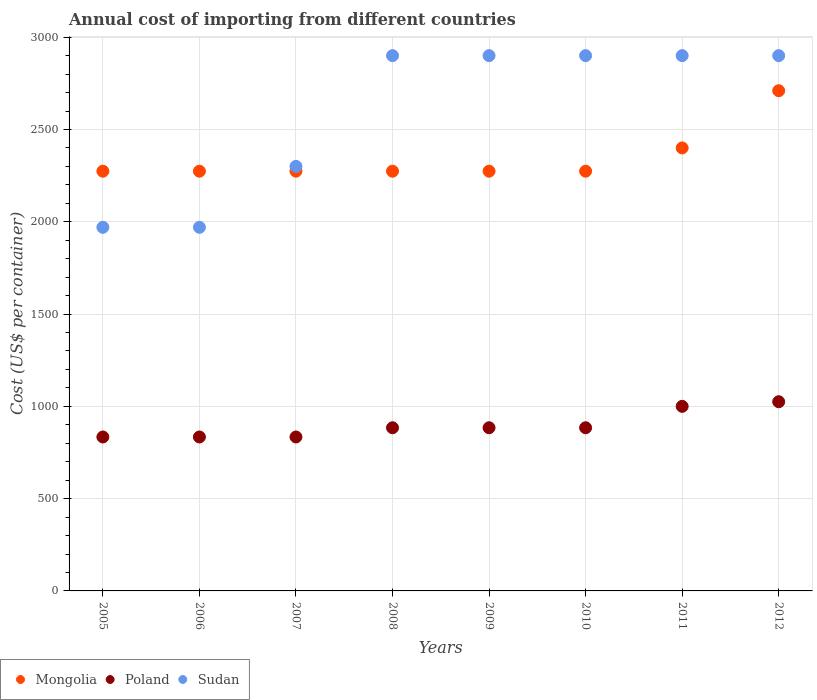What is the total annual cost of importing in Poland in 2005?
Your answer should be very brief. 834. Across all years, what is the maximum total annual cost of importing in Poland?
Keep it short and to the point. 1025. Across all years, what is the minimum total annual cost of importing in Poland?
Keep it short and to the point. 834. In which year was the total annual cost of importing in Sudan minimum?
Offer a very short reply. 2005. What is the total total annual cost of importing in Sudan in the graph?
Your answer should be very brief. 2.07e+04. What is the difference between the total annual cost of importing in Sudan in 2005 and that in 2011?
Ensure brevity in your answer.  -930. What is the difference between the total annual cost of importing in Poland in 2006 and the total annual cost of importing in Mongolia in 2007?
Your answer should be compact. -1440. What is the average total annual cost of importing in Mongolia per year?
Ensure brevity in your answer.  2344.25. In the year 2006, what is the difference between the total annual cost of importing in Sudan and total annual cost of importing in Mongolia?
Your answer should be very brief. -304. What is the difference between the highest and the second highest total annual cost of importing in Mongolia?
Give a very brief answer. 310. What is the difference between the highest and the lowest total annual cost of importing in Poland?
Make the answer very short. 191. In how many years, is the total annual cost of importing in Poland greater than the average total annual cost of importing in Poland taken over all years?
Your answer should be very brief. 2. Is it the case that in every year, the sum of the total annual cost of importing in Sudan and total annual cost of importing in Poland  is greater than the total annual cost of importing in Mongolia?
Give a very brief answer. Yes. Does the total annual cost of importing in Mongolia monotonically increase over the years?
Your response must be concise. No. Is the total annual cost of importing in Sudan strictly greater than the total annual cost of importing in Poland over the years?
Your answer should be very brief. Yes. Is the total annual cost of importing in Mongolia strictly less than the total annual cost of importing in Poland over the years?
Keep it short and to the point. No. How many dotlines are there?
Give a very brief answer. 3. What is the difference between two consecutive major ticks on the Y-axis?
Your answer should be compact. 500. Does the graph contain any zero values?
Your answer should be compact. No. Does the graph contain grids?
Keep it short and to the point. Yes. How many legend labels are there?
Your response must be concise. 3. What is the title of the graph?
Your answer should be compact. Annual cost of importing from different countries. What is the label or title of the Y-axis?
Give a very brief answer. Cost (US$ per container). What is the Cost (US$ per container) of Mongolia in 2005?
Offer a very short reply. 2274. What is the Cost (US$ per container) in Poland in 2005?
Your response must be concise. 834. What is the Cost (US$ per container) in Sudan in 2005?
Ensure brevity in your answer.  1970. What is the Cost (US$ per container) in Mongolia in 2006?
Keep it short and to the point. 2274. What is the Cost (US$ per container) of Poland in 2006?
Ensure brevity in your answer.  834. What is the Cost (US$ per container) of Sudan in 2006?
Your response must be concise. 1970. What is the Cost (US$ per container) in Mongolia in 2007?
Provide a short and direct response. 2274. What is the Cost (US$ per container) in Poland in 2007?
Keep it short and to the point. 834. What is the Cost (US$ per container) in Sudan in 2007?
Give a very brief answer. 2300. What is the Cost (US$ per container) of Mongolia in 2008?
Your answer should be compact. 2274. What is the Cost (US$ per container) of Poland in 2008?
Offer a terse response. 884. What is the Cost (US$ per container) in Sudan in 2008?
Offer a terse response. 2900. What is the Cost (US$ per container) of Mongolia in 2009?
Your answer should be very brief. 2274. What is the Cost (US$ per container) of Poland in 2009?
Your answer should be very brief. 884. What is the Cost (US$ per container) in Sudan in 2009?
Your answer should be very brief. 2900. What is the Cost (US$ per container) of Mongolia in 2010?
Make the answer very short. 2274. What is the Cost (US$ per container) of Poland in 2010?
Provide a succinct answer. 884. What is the Cost (US$ per container) in Sudan in 2010?
Provide a short and direct response. 2900. What is the Cost (US$ per container) of Mongolia in 2011?
Provide a short and direct response. 2400. What is the Cost (US$ per container) of Poland in 2011?
Give a very brief answer. 1000. What is the Cost (US$ per container) in Sudan in 2011?
Offer a very short reply. 2900. What is the Cost (US$ per container) of Mongolia in 2012?
Ensure brevity in your answer.  2710. What is the Cost (US$ per container) of Poland in 2012?
Provide a succinct answer. 1025. What is the Cost (US$ per container) of Sudan in 2012?
Offer a terse response. 2900. Across all years, what is the maximum Cost (US$ per container) in Mongolia?
Ensure brevity in your answer.  2710. Across all years, what is the maximum Cost (US$ per container) in Poland?
Your response must be concise. 1025. Across all years, what is the maximum Cost (US$ per container) in Sudan?
Offer a terse response. 2900. Across all years, what is the minimum Cost (US$ per container) of Mongolia?
Your response must be concise. 2274. Across all years, what is the minimum Cost (US$ per container) in Poland?
Offer a very short reply. 834. Across all years, what is the minimum Cost (US$ per container) of Sudan?
Provide a succinct answer. 1970. What is the total Cost (US$ per container) in Mongolia in the graph?
Your answer should be compact. 1.88e+04. What is the total Cost (US$ per container) of Poland in the graph?
Your answer should be very brief. 7179. What is the total Cost (US$ per container) in Sudan in the graph?
Offer a very short reply. 2.07e+04. What is the difference between the Cost (US$ per container) in Mongolia in 2005 and that in 2007?
Provide a short and direct response. 0. What is the difference between the Cost (US$ per container) of Poland in 2005 and that in 2007?
Offer a terse response. 0. What is the difference between the Cost (US$ per container) of Sudan in 2005 and that in 2007?
Keep it short and to the point. -330. What is the difference between the Cost (US$ per container) of Poland in 2005 and that in 2008?
Your answer should be very brief. -50. What is the difference between the Cost (US$ per container) in Sudan in 2005 and that in 2008?
Offer a terse response. -930. What is the difference between the Cost (US$ per container) in Sudan in 2005 and that in 2009?
Your response must be concise. -930. What is the difference between the Cost (US$ per container) of Mongolia in 2005 and that in 2010?
Your response must be concise. 0. What is the difference between the Cost (US$ per container) in Sudan in 2005 and that in 2010?
Provide a short and direct response. -930. What is the difference between the Cost (US$ per container) in Mongolia in 2005 and that in 2011?
Ensure brevity in your answer.  -126. What is the difference between the Cost (US$ per container) of Poland in 2005 and that in 2011?
Provide a short and direct response. -166. What is the difference between the Cost (US$ per container) of Sudan in 2005 and that in 2011?
Ensure brevity in your answer.  -930. What is the difference between the Cost (US$ per container) in Mongolia in 2005 and that in 2012?
Offer a terse response. -436. What is the difference between the Cost (US$ per container) of Poland in 2005 and that in 2012?
Your answer should be compact. -191. What is the difference between the Cost (US$ per container) of Sudan in 2005 and that in 2012?
Ensure brevity in your answer.  -930. What is the difference between the Cost (US$ per container) in Mongolia in 2006 and that in 2007?
Offer a terse response. 0. What is the difference between the Cost (US$ per container) in Sudan in 2006 and that in 2007?
Keep it short and to the point. -330. What is the difference between the Cost (US$ per container) in Poland in 2006 and that in 2008?
Your response must be concise. -50. What is the difference between the Cost (US$ per container) of Sudan in 2006 and that in 2008?
Ensure brevity in your answer.  -930. What is the difference between the Cost (US$ per container) in Mongolia in 2006 and that in 2009?
Your response must be concise. 0. What is the difference between the Cost (US$ per container) of Poland in 2006 and that in 2009?
Your answer should be compact. -50. What is the difference between the Cost (US$ per container) in Sudan in 2006 and that in 2009?
Your answer should be very brief. -930. What is the difference between the Cost (US$ per container) of Sudan in 2006 and that in 2010?
Your response must be concise. -930. What is the difference between the Cost (US$ per container) in Mongolia in 2006 and that in 2011?
Provide a succinct answer. -126. What is the difference between the Cost (US$ per container) in Poland in 2006 and that in 2011?
Offer a terse response. -166. What is the difference between the Cost (US$ per container) of Sudan in 2006 and that in 2011?
Offer a terse response. -930. What is the difference between the Cost (US$ per container) in Mongolia in 2006 and that in 2012?
Offer a terse response. -436. What is the difference between the Cost (US$ per container) in Poland in 2006 and that in 2012?
Ensure brevity in your answer.  -191. What is the difference between the Cost (US$ per container) of Sudan in 2006 and that in 2012?
Ensure brevity in your answer.  -930. What is the difference between the Cost (US$ per container) of Mongolia in 2007 and that in 2008?
Your answer should be very brief. 0. What is the difference between the Cost (US$ per container) in Sudan in 2007 and that in 2008?
Ensure brevity in your answer.  -600. What is the difference between the Cost (US$ per container) of Sudan in 2007 and that in 2009?
Make the answer very short. -600. What is the difference between the Cost (US$ per container) of Mongolia in 2007 and that in 2010?
Give a very brief answer. 0. What is the difference between the Cost (US$ per container) of Sudan in 2007 and that in 2010?
Offer a very short reply. -600. What is the difference between the Cost (US$ per container) of Mongolia in 2007 and that in 2011?
Offer a very short reply. -126. What is the difference between the Cost (US$ per container) of Poland in 2007 and that in 2011?
Offer a very short reply. -166. What is the difference between the Cost (US$ per container) in Sudan in 2007 and that in 2011?
Keep it short and to the point. -600. What is the difference between the Cost (US$ per container) of Mongolia in 2007 and that in 2012?
Ensure brevity in your answer.  -436. What is the difference between the Cost (US$ per container) in Poland in 2007 and that in 2012?
Provide a succinct answer. -191. What is the difference between the Cost (US$ per container) in Sudan in 2007 and that in 2012?
Ensure brevity in your answer.  -600. What is the difference between the Cost (US$ per container) of Mongolia in 2008 and that in 2009?
Make the answer very short. 0. What is the difference between the Cost (US$ per container) of Poland in 2008 and that in 2009?
Your response must be concise. 0. What is the difference between the Cost (US$ per container) in Sudan in 2008 and that in 2009?
Your response must be concise. 0. What is the difference between the Cost (US$ per container) in Poland in 2008 and that in 2010?
Provide a succinct answer. 0. What is the difference between the Cost (US$ per container) in Mongolia in 2008 and that in 2011?
Make the answer very short. -126. What is the difference between the Cost (US$ per container) of Poland in 2008 and that in 2011?
Ensure brevity in your answer.  -116. What is the difference between the Cost (US$ per container) in Mongolia in 2008 and that in 2012?
Offer a terse response. -436. What is the difference between the Cost (US$ per container) in Poland in 2008 and that in 2012?
Offer a very short reply. -141. What is the difference between the Cost (US$ per container) in Sudan in 2008 and that in 2012?
Make the answer very short. 0. What is the difference between the Cost (US$ per container) of Mongolia in 2009 and that in 2010?
Your answer should be compact. 0. What is the difference between the Cost (US$ per container) of Sudan in 2009 and that in 2010?
Make the answer very short. 0. What is the difference between the Cost (US$ per container) in Mongolia in 2009 and that in 2011?
Offer a very short reply. -126. What is the difference between the Cost (US$ per container) of Poland in 2009 and that in 2011?
Provide a succinct answer. -116. What is the difference between the Cost (US$ per container) in Mongolia in 2009 and that in 2012?
Provide a short and direct response. -436. What is the difference between the Cost (US$ per container) in Poland in 2009 and that in 2012?
Keep it short and to the point. -141. What is the difference between the Cost (US$ per container) of Mongolia in 2010 and that in 2011?
Ensure brevity in your answer.  -126. What is the difference between the Cost (US$ per container) of Poland in 2010 and that in 2011?
Your answer should be compact. -116. What is the difference between the Cost (US$ per container) of Mongolia in 2010 and that in 2012?
Ensure brevity in your answer.  -436. What is the difference between the Cost (US$ per container) in Poland in 2010 and that in 2012?
Your answer should be very brief. -141. What is the difference between the Cost (US$ per container) of Sudan in 2010 and that in 2012?
Make the answer very short. 0. What is the difference between the Cost (US$ per container) in Mongolia in 2011 and that in 2012?
Offer a very short reply. -310. What is the difference between the Cost (US$ per container) of Sudan in 2011 and that in 2012?
Provide a succinct answer. 0. What is the difference between the Cost (US$ per container) in Mongolia in 2005 and the Cost (US$ per container) in Poland in 2006?
Your answer should be very brief. 1440. What is the difference between the Cost (US$ per container) in Mongolia in 2005 and the Cost (US$ per container) in Sudan in 2006?
Keep it short and to the point. 304. What is the difference between the Cost (US$ per container) in Poland in 2005 and the Cost (US$ per container) in Sudan in 2006?
Offer a terse response. -1136. What is the difference between the Cost (US$ per container) of Mongolia in 2005 and the Cost (US$ per container) of Poland in 2007?
Provide a short and direct response. 1440. What is the difference between the Cost (US$ per container) of Poland in 2005 and the Cost (US$ per container) of Sudan in 2007?
Your response must be concise. -1466. What is the difference between the Cost (US$ per container) of Mongolia in 2005 and the Cost (US$ per container) of Poland in 2008?
Your answer should be compact. 1390. What is the difference between the Cost (US$ per container) in Mongolia in 2005 and the Cost (US$ per container) in Sudan in 2008?
Provide a succinct answer. -626. What is the difference between the Cost (US$ per container) in Poland in 2005 and the Cost (US$ per container) in Sudan in 2008?
Offer a very short reply. -2066. What is the difference between the Cost (US$ per container) of Mongolia in 2005 and the Cost (US$ per container) of Poland in 2009?
Ensure brevity in your answer.  1390. What is the difference between the Cost (US$ per container) in Mongolia in 2005 and the Cost (US$ per container) in Sudan in 2009?
Your answer should be compact. -626. What is the difference between the Cost (US$ per container) of Poland in 2005 and the Cost (US$ per container) of Sudan in 2009?
Your response must be concise. -2066. What is the difference between the Cost (US$ per container) in Mongolia in 2005 and the Cost (US$ per container) in Poland in 2010?
Keep it short and to the point. 1390. What is the difference between the Cost (US$ per container) of Mongolia in 2005 and the Cost (US$ per container) of Sudan in 2010?
Keep it short and to the point. -626. What is the difference between the Cost (US$ per container) of Poland in 2005 and the Cost (US$ per container) of Sudan in 2010?
Offer a very short reply. -2066. What is the difference between the Cost (US$ per container) in Mongolia in 2005 and the Cost (US$ per container) in Poland in 2011?
Offer a terse response. 1274. What is the difference between the Cost (US$ per container) in Mongolia in 2005 and the Cost (US$ per container) in Sudan in 2011?
Make the answer very short. -626. What is the difference between the Cost (US$ per container) in Poland in 2005 and the Cost (US$ per container) in Sudan in 2011?
Give a very brief answer. -2066. What is the difference between the Cost (US$ per container) of Mongolia in 2005 and the Cost (US$ per container) of Poland in 2012?
Give a very brief answer. 1249. What is the difference between the Cost (US$ per container) in Mongolia in 2005 and the Cost (US$ per container) in Sudan in 2012?
Keep it short and to the point. -626. What is the difference between the Cost (US$ per container) in Poland in 2005 and the Cost (US$ per container) in Sudan in 2012?
Offer a terse response. -2066. What is the difference between the Cost (US$ per container) of Mongolia in 2006 and the Cost (US$ per container) of Poland in 2007?
Provide a short and direct response. 1440. What is the difference between the Cost (US$ per container) in Poland in 2006 and the Cost (US$ per container) in Sudan in 2007?
Offer a terse response. -1466. What is the difference between the Cost (US$ per container) in Mongolia in 2006 and the Cost (US$ per container) in Poland in 2008?
Give a very brief answer. 1390. What is the difference between the Cost (US$ per container) in Mongolia in 2006 and the Cost (US$ per container) in Sudan in 2008?
Offer a terse response. -626. What is the difference between the Cost (US$ per container) in Poland in 2006 and the Cost (US$ per container) in Sudan in 2008?
Your answer should be very brief. -2066. What is the difference between the Cost (US$ per container) of Mongolia in 2006 and the Cost (US$ per container) of Poland in 2009?
Provide a succinct answer. 1390. What is the difference between the Cost (US$ per container) of Mongolia in 2006 and the Cost (US$ per container) of Sudan in 2009?
Offer a very short reply. -626. What is the difference between the Cost (US$ per container) in Poland in 2006 and the Cost (US$ per container) in Sudan in 2009?
Your response must be concise. -2066. What is the difference between the Cost (US$ per container) in Mongolia in 2006 and the Cost (US$ per container) in Poland in 2010?
Keep it short and to the point. 1390. What is the difference between the Cost (US$ per container) of Mongolia in 2006 and the Cost (US$ per container) of Sudan in 2010?
Give a very brief answer. -626. What is the difference between the Cost (US$ per container) of Poland in 2006 and the Cost (US$ per container) of Sudan in 2010?
Your answer should be very brief. -2066. What is the difference between the Cost (US$ per container) of Mongolia in 2006 and the Cost (US$ per container) of Poland in 2011?
Offer a terse response. 1274. What is the difference between the Cost (US$ per container) in Mongolia in 2006 and the Cost (US$ per container) in Sudan in 2011?
Your response must be concise. -626. What is the difference between the Cost (US$ per container) of Poland in 2006 and the Cost (US$ per container) of Sudan in 2011?
Give a very brief answer. -2066. What is the difference between the Cost (US$ per container) in Mongolia in 2006 and the Cost (US$ per container) in Poland in 2012?
Offer a very short reply. 1249. What is the difference between the Cost (US$ per container) of Mongolia in 2006 and the Cost (US$ per container) of Sudan in 2012?
Provide a succinct answer. -626. What is the difference between the Cost (US$ per container) of Poland in 2006 and the Cost (US$ per container) of Sudan in 2012?
Ensure brevity in your answer.  -2066. What is the difference between the Cost (US$ per container) of Mongolia in 2007 and the Cost (US$ per container) of Poland in 2008?
Your answer should be compact. 1390. What is the difference between the Cost (US$ per container) in Mongolia in 2007 and the Cost (US$ per container) in Sudan in 2008?
Provide a short and direct response. -626. What is the difference between the Cost (US$ per container) of Poland in 2007 and the Cost (US$ per container) of Sudan in 2008?
Keep it short and to the point. -2066. What is the difference between the Cost (US$ per container) in Mongolia in 2007 and the Cost (US$ per container) in Poland in 2009?
Provide a succinct answer. 1390. What is the difference between the Cost (US$ per container) of Mongolia in 2007 and the Cost (US$ per container) of Sudan in 2009?
Your answer should be very brief. -626. What is the difference between the Cost (US$ per container) in Poland in 2007 and the Cost (US$ per container) in Sudan in 2009?
Provide a succinct answer. -2066. What is the difference between the Cost (US$ per container) of Mongolia in 2007 and the Cost (US$ per container) of Poland in 2010?
Keep it short and to the point. 1390. What is the difference between the Cost (US$ per container) in Mongolia in 2007 and the Cost (US$ per container) in Sudan in 2010?
Ensure brevity in your answer.  -626. What is the difference between the Cost (US$ per container) in Poland in 2007 and the Cost (US$ per container) in Sudan in 2010?
Your answer should be very brief. -2066. What is the difference between the Cost (US$ per container) of Mongolia in 2007 and the Cost (US$ per container) of Poland in 2011?
Provide a short and direct response. 1274. What is the difference between the Cost (US$ per container) of Mongolia in 2007 and the Cost (US$ per container) of Sudan in 2011?
Keep it short and to the point. -626. What is the difference between the Cost (US$ per container) in Poland in 2007 and the Cost (US$ per container) in Sudan in 2011?
Offer a very short reply. -2066. What is the difference between the Cost (US$ per container) in Mongolia in 2007 and the Cost (US$ per container) in Poland in 2012?
Provide a succinct answer. 1249. What is the difference between the Cost (US$ per container) of Mongolia in 2007 and the Cost (US$ per container) of Sudan in 2012?
Ensure brevity in your answer.  -626. What is the difference between the Cost (US$ per container) of Poland in 2007 and the Cost (US$ per container) of Sudan in 2012?
Your answer should be compact. -2066. What is the difference between the Cost (US$ per container) of Mongolia in 2008 and the Cost (US$ per container) of Poland in 2009?
Ensure brevity in your answer.  1390. What is the difference between the Cost (US$ per container) in Mongolia in 2008 and the Cost (US$ per container) in Sudan in 2009?
Offer a very short reply. -626. What is the difference between the Cost (US$ per container) in Poland in 2008 and the Cost (US$ per container) in Sudan in 2009?
Ensure brevity in your answer.  -2016. What is the difference between the Cost (US$ per container) in Mongolia in 2008 and the Cost (US$ per container) in Poland in 2010?
Give a very brief answer. 1390. What is the difference between the Cost (US$ per container) in Mongolia in 2008 and the Cost (US$ per container) in Sudan in 2010?
Ensure brevity in your answer.  -626. What is the difference between the Cost (US$ per container) in Poland in 2008 and the Cost (US$ per container) in Sudan in 2010?
Give a very brief answer. -2016. What is the difference between the Cost (US$ per container) of Mongolia in 2008 and the Cost (US$ per container) of Poland in 2011?
Give a very brief answer. 1274. What is the difference between the Cost (US$ per container) of Mongolia in 2008 and the Cost (US$ per container) of Sudan in 2011?
Ensure brevity in your answer.  -626. What is the difference between the Cost (US$ per container) in Poland in 2008 and the Cost (US$ per container) in Sudan in 2011?
Offer a very short reply. -2016. What is the difference between the Cost (US$ per container) in Mongolia in 2008 and the Cost (US$ per container) in Poland in 2012?
Your answer should be very brief. 1249. What is the difference between the Cost (US$ per container) in Mongolia in 2008 and the Cost (US$ per container) in Sudan in 2012?
Make the answer very short. -626. What is the difference between the Cost (US$ per container) in Poland in 2008 and the Cost (US$ per container) in Sudan in 2012?
Make the answer very short. -2016. What is the difference between the Cost (US$ per container) in Mongolia in 2009 and the Cost (US$ per container) in Poland in 2010?
Your answer should be very brief. 1390. What is the difference between the Cost (US$ per container) of Mongolia in 2009 and the Cost (US$ per container) of Sudan in 2010?
Make the answer very short. -626. What is the difference between the Cost (US$ per container) of Poland in 2009 and the Cost (US$ per container) of Sudan in 2010?
Your response must be concise. -2016. What is the difference between the Cost (US$ per container) of Mongolia in 2009 and the Cost (US$ per container) of Poland in 2011?
Offer a very short reply. 1274. What is the difference between the Cost (US$ per container) of Mongolia in 2009 and the Cost (US$ per container) of Sudan in 2011?
Your response must be concise. -626. What is the difference between the Cost (US$ per container) of Poland in 2009 and the Cost (US$ per container) of Sudan in 2011?
Provide a succinct answer. -2016. What is the difference between the Cost (US$ per container) of Mongolia in 2009 and the Cost (US$ per container) of Poland in 2012?
Provide a short and direct response. 1249. What is the difference between the Cost (US$ per container) of Mongolia in 2009 and the Cost (US$ per container) of Sudan in 2012?
Make the answer very short. -626. What is the difference between the Cost (US$ per container) in Poland in 2009 and the Cost (US$ per container) in Sudan in 2012?
Provide a succinct answer. -2016. What is the difference between the Cost (US$ per container) in Mongolia in 2010 and the Cost (US$ per container) in Poland in 2011?
Ensure brevity in your answer.  1274. What is the difference between the Cost (US$ per container) in Mongolia in 2010 and the Cost (US$ per container) in Sudan in 2011?
Make the answer very short. -626. What is the difference between the Cost (US$ per container) of Poland in 2010 and the Cost (US$ per container) of Sudan in 2011?
Ensure brevity in your answer.  -2016. What is the difference between the Cost (US$ per container) of Mongolia in 2010 and the Cost (US$ per container) of Poland in 2012?
Your answer should be very brief. 1249. What is the difference between the Cost (US$ per container) in Mongolia in 2010 and the Cost (US$ per container) in Sudan in 2012?
Ensure brevity in your answer.  -626. What is the difference between the Cost (US$ per container) of Poland in 2010 and the Cost (US$ per container) of Sudan in 2012?
Ensure brevity in your answer.  -2016. What is the difference between the Cost (US$ per container) of Mongolia in 2011 and the Cost (US$ per container) of Poland in 2012?
Provide a succinct answer. 1375. What is the difference between the Cost (US$ per container) of Mongolia in 2011 and the Cost (US$ per container) of Sudan in 2012?
Give a very brief answer. -500. What is the difference between the Cost (US$ per container) of Poland in 2011 and the Cost (US$ per container) of Sudan in 2012?
Provide a succinct answer. -1900. What is the average Cost (US$ per container) of Mongolia per year?
Make the answer very short. 2344.25. What is the average Cost (US$ per container) of Poland per year?
Provide a short and direct response. 897.38. What is the average Cost (US$ per container) in Sudan per year?
Your answer should be very brief. 2592.5. In the year 2005, what is the difference between the Cost (US$ per container) of Mongolia and Cost (US$ per container) of Poland?
Keep it short and to the point. 1440. In the year 2005, what is the difference between the Cost (US$ per container) in Mongolia and Cost (US$ per container) in Sudan?
Keep it short and to the point. 304. In the year 2005, what is the difference between the Cost (US$ per container) in Poland and Cost (US$ per container) in Sudan?
Your answer should be very brief. -1136. In the year 2006, what is the difference between the Cost (US$ per container) of Mongolia and Cost (US$ per container) of Poland?
Your answer should be compact. 1440. In the year 2006, what is the difference between the Cost (US$ per container) of Mongolia and Cost (US$ per container) of Sudan?
Make the answer very short. 304. In the year 2006, what is the difference between the Cost (US$ per container) of Poland and Cost (US$ per container) of Sudan?
Your answer should be compact. -1136. In the year 2007, what is the difference between the Cost (US$ per container) of Mongolia and Cost (US$ per container) of Poland?
Your answer should be very brief. 1440. In the year 2007, what is the difference between the Cost (US$ per container) of Poland and Cost (US$ per container) of Sudan?
Make the answer very short. -1466. In the year 2008, what is the difference between the Cost (US$ per container) of Mongolia and Cost (US$ per container) of Poland?
Your answer should be very brief. 1390. In the year 2008, what is the difference between the Cost (US$ per container) of Mongolia and Cost (US$ per container) of Sudan?
Provide a short and direct response. -626. In the year 2008, what is the difference between the Cost (US$ per container) of Poland and Cost (US$ per container) of Sudan?
Your answer should be very brief. -2016. In the year 2009, what is the difference between the Cost (US$ per container) of Mongolia and Cost (US$ per container) of Poland?
Offer a terse response. 1390. In the year 2009, what is the difference between the Cost (US$ per container) in Mongolia and Cost (US$ per container) in Sudan?
Offer a terse response. -626. In the year 2009, what is the difference between the Cost (US$ per container) in Poland and Cost (US$ per container) in Sudan?
Provide a succinct answer. -2016. In the year 2010, what is the difference between the Cost (US$ per container) in Mongolia and Cost (US$ per container) in Poland?
Your response must be concise. 1390. In the year 2010, what is the difference between the Cost (US$ per container) in Mongolia and Cost (US$ per container) in Sudan?
Your response must be concise. -626. In the year 2010, what is the difference between the Cost (US$ per container) in Poland and Cost (US$ per container) in Sudan?
Ensure brevity in your answer.  -2016. In the year 2011, what is the difference between the Cost (US$ per container) of Mongolia and Cost (US$ per container) of Poland?
Make the answer very short. 1400. In the year 2011, what is the difference between the Cost (US$ per container) in Mongolia and Cost (US$ per container) in Sudan?
Your response must be concise. -500. In the year 2011, what is the difference between the Cost (US$ per container) of Poland and Cost (US$ per container) of Sudan?
Offer a terse response. -1900. In the year 2012, what is the difference between the Cost (US$ per container) in Mongolia and Cost (US$ per container) in Poland?
Give a very brief answer. 1685. In the year 2012, what is the difference between the Cost (US$ per container) of Mongolia and Cost (US$ per container) of Sudan?
Your answer should be compact. -190. In the year 2012, what is the difference between the Cost (US$ per container) of Poland and Cost (US$ per container) of Sudan?
Offer a terse response. -1875. What is the ratio of the Cost (US$ per container) of Mongolia in 2005 to that in 2006?
Your answer should be compact. 1. What is the ratio of the Cost (US$ per container) of Poland in 2005 to that in 2006?
Your answer should be very brief. 1. What is the ratio of the Cost (US$ per container) of Poland in 2005 to that in 2007?
Ensure brevity in your answer.  1. What is the ratio of the Cost (US$ per container) in Sudan in 2005 to that in 2007?
Keep it short and to the point. 0.86. What is the ratio of the Cost (US$ per container) in Mongolia in 2005 to that in 2008?
Keep it short and to the point. 1. What is the ratio of the Cost (US$ per container) in Poland in 2005 to that in 2008?
Provide a succinct answer. 0.94. What is the ratio of the Cost (US$ per container) of Sudan in 2005 to that in 2008?
Provide a succinct answer. 0.68. What is the ratio of the Cost (US$ per container) of Mongolia in 2005 to that in 2009?
Provide a short and direct response. 1. What is the ratio of the Cost (US$ per container) in Poland in 2005 to that in 2009?
Your answer should be compact. 0.94. What is the ratio of the Cost (US$ per container) in Sudan in 2005 to that in 2009?
Ensure brevity in your answer.  0.68. What is the ratio of the Cost (US$ per container) of Poland in 2005 to that in 2010?
Make the answer very short. 0.94. What is the ratio of the Cost (US$ per container) in Sudan in 2005 to that in 2010?
Your answer should be very brief. 0.68. What is the ratio of the Cost (US$ per container) of Mongolia in 2005 to that in 2011?
Your answer should be compact. 0.95. What is the ratio of the Cost (US$ per container) in Poland in 2005 to that in 2011?
Provide a short and direct response. 0.83. What is the ratio of the Cost (US$ per container) in Sudan in 2005 to that in 2011?
Keep it short and to the point. 0.68. What is the ratio of the Cost (US$ per container) of Mongolia in 2005 to that in 2012?
Ensure brevity in your answer.  0.84. What is the ratio of the Cost (US$ per container) of Poland in 2005 to that in 2012?
Offer a terse response. 0.81. What is the ratio of the Cost (US$ per container) of Sudan in 2005 to that in 2012?
Your answer should be compact. 0.68. What is the ratio of the Cost (US$ per container) of Mongolia in 2006 to that in 2007?
Make the answer very short. 1. What is the ratio of the Cost (US$ per container) of Poland in 2006 to that in 2007?
Ensure brevity in your answer.  1. What is the ratio of the Cost (US$ per container) in Sudan in 2006 to that in 2007?
Offer a very short reply. 0.86. What is the ratio of the Cost (US$ per container) in Poland in 2006 to that in 2008?
Your response must be concise. 0.94. What is the ratio of the Cost (US$ per container) of Sudan in 2006 to that in 2008?
Make the answer very short. 0.68. What is the ratio of the Cost (US$ per container) of Mongolia in 2006 to that in 2009?
Offer a very short reply. 1. What is the ratio of the Cost (US$ per container) in Poland in 2006 to that in 2009?
Provide a succinct answer. 0.94. What is the ratio of the Cost (US$ per container) in Sudan in 2006 to that in 2009?
Provide a short and direct response. 0.68. What is the ratio of the Cost (US$ per container) of Poland in 2006 to that in 2010?
Ensure brevity in your answer.  0.94. What is the ratio of the Cost (US$ per container) of Sudan in 2006 to that in 2010?
Make the answer very short. 0.68. What is the ratio of the Cost (US$ per container) in Mongolia in 2006 to that in 2011?
Your response must be concise. 0.95. What is the ratio of the Cost (US$ per container) in Poland in 2006 to that in 2011?
Your response must be concise. 0.83. What is the ratio of the Cost (US$ per container) of Sudan in 2006 to that in 2011?
Keep it short and to the point. 0.68. What is the ratio of the Cost (US$ per container) of Mongolia in 2006 to that in 2012?
Offer a very short reply. 0.84. What is the ratio of the Cost (US$ per container) in Poland in 2006 to that in 2012?
Give a very brief answer. 0.81. What is the ratio of the Cost (US$ per container) in Sudan in 2006 to that in 2012?
Make the answer very short. 0.68. What is the ratio of the Cost (US$ per container) in Mongolia in 2007 to that in 2008?
Provide a succinct answer. 1. What is the ratio of the Cost (US$ per container) in Poland in 2007 to that in 2008?
Your response must be concise. 0.94. What is the ratio of the Cost (US$ per container) of Sudan in 2007 to that in 2008?
Make the answer very short. 0.79. What is the ratio of the Cost (US$ per container) of Poland in 2007 to that in 2009?
Make the answer very short. 0.94. What is the ratio of the Cost (US$ per container) in Sudan in 2007 to that in 2009?
Keep it short and to the point. 0.79. What is the ratio of the Cost (US$ per container) in Poland in 2007 to that in 2010?
Offer a terse response. 0.94. What is the ratio of the Cost (US$ per container) in Sudan in 2007 to that in 2010?
Make the answer very short. 0.79. What is the ratio of the Cost (US$ per container) in Mongolia in 2007 to that in 2011?
Offer a very short reply. 0.95. What is the ratio of the Cost (US$ per container) in Poland in 2007 to that in 2011?
Ensure brevity in your answer.  0.83. What is the ratio of the Cost (US$ per container) in Sudan in 2007 to that in 2011?
Give a very brief answer. 0.79. What is the ratio of the Cost (US$ per container) in Mongolia in 2007 to that in 2012?
Make the answer very short. 0.84. What is the ratio of the Cost (US$ per container) in Poland in 2007 to that in 2012?
Give a very brief answer. 0.81. What is the ratio of the Cost (US$ per container) of Sudan in 2007 to that in 2012?
Your response must be concise. 0.79. What is the ratio of the Cost (US$ per container) in Sudan in 2008 to that in 2009?
Your response must be concise. 1. What is the ratio of the Cost (US$ per container) in Poland in 2008 to that in 2010?
Your answer should be compact. 1. What is the ratio of the Cost (US$ per container) of Mongolia in 2008 to that in 2011?
Give a very brief answer. 0.95. What is the ratio of the Cost (US$ per container) in Poland in 2008 to that in 2011?
Your answer should be very brief. 0.88. What is the ratio of the Cost (US$ per container) in Mongolia in 2008 to that in 2012?
Your answer should be very brief. 0.84. What is the ratio of the Cost (US$ per container) of Poland in 2008 to that in 2012?
Offer a very short reply. 0.86. What is the ratio of the Cost (US$ per container) in Sudan in 2008 to that in 2012?
Keep it short and to the point. 1. What is the ratio of the Cost (US$ per container) of Mongolia in 2009 to that in 2010?
Your answer should be very brief. 1. What is the ratio of the Cost (US$ per container) in Sudan in 2009 to that in 2010?
Keep it short and to the point. 1. What is the ratio of the Cost (US$ per container) in Mongolia in 2009 to that in 2011?
Make the answer very short. 0.95. What is the ratio of the Cost (US$ per container) in Poland in 2009 to that in 2011?
Keep it short and to the point. 0.88. What is the ratio of the Cost (US$ per container) of Mongolia in 2009 to that in 2012?
Provide a succinct answer. 0.84. What is the ratio of the Cost (US$ per container) of Poland in 2009 to that in 2012?
Your response must be concise. 0.86. What is the ratio of the Cost (US$ per container) in Mongolia in 2010 to that in 2011?
Your response must be concise. 0.95. What is the ratio of the Cost (US$ per container) of Poland in 2010 to that in 2011?
Provide a succinct answer. 0.88. What is the ratio of the Cost (US$ per container) of Mongolia in 2010 to that in 2012?
Keep it short and to the point. 0.84. What is the ratio of the Cost (US$ per container) in Poland in 2010 to that in 2012?
Provide a short and direct response. 0.86. What is the ratio of the Cost (US$ per container) in Mongolia in 2011 to that in 2012?
Your answer should be compact. 0.89. What is the ratio of the Cost (US$ per container) of Poland in 2011 to that in 2012?
Provide a short and direct response. 0.98. What is the difference between the highest and the second highest Cost (US$ per container) of Mongolia?
Offer a terse response. 310. What is the difference between the highest and the second highest Cost (US$ per container) in Poland?
Your answer should be very brief. 25. What is the difference between the highest and the lowest Cost (US$ per container) of Mongolia?
Give a very brief answer. 436. What is the difference between the highest and the lowest Cost (US$ per container) of Poland?
Provide a short and direct response. 191. What is the difference between the highest and the lowest Cost (US$ per container) in Sudan?
Provide a short and direct response. 930. 